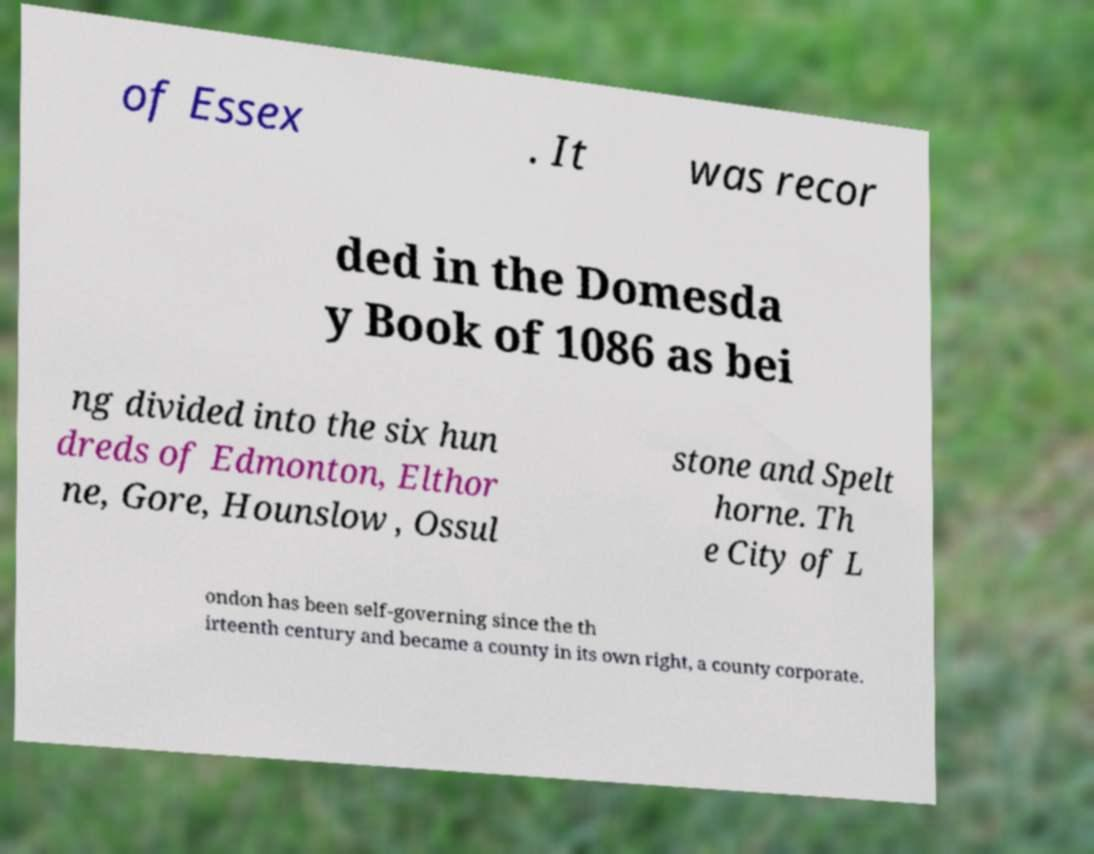There's text embedded in this image that I need extracted. Can you transcribe it verbatim? of Essex . It was recor ded in the Domesda y Book of 1086 as bei ng divided into the six hun dreds of Edmonton, Elthor ne, Gore, Hounslow , Ossul stone and Spelt horne. Th e City of L ondon has been self-governing since the th irteenth century and became a county in its own right, a county corporate. 